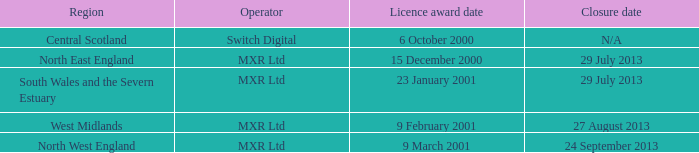What is the license award date for North East England? 15 December 2000. 